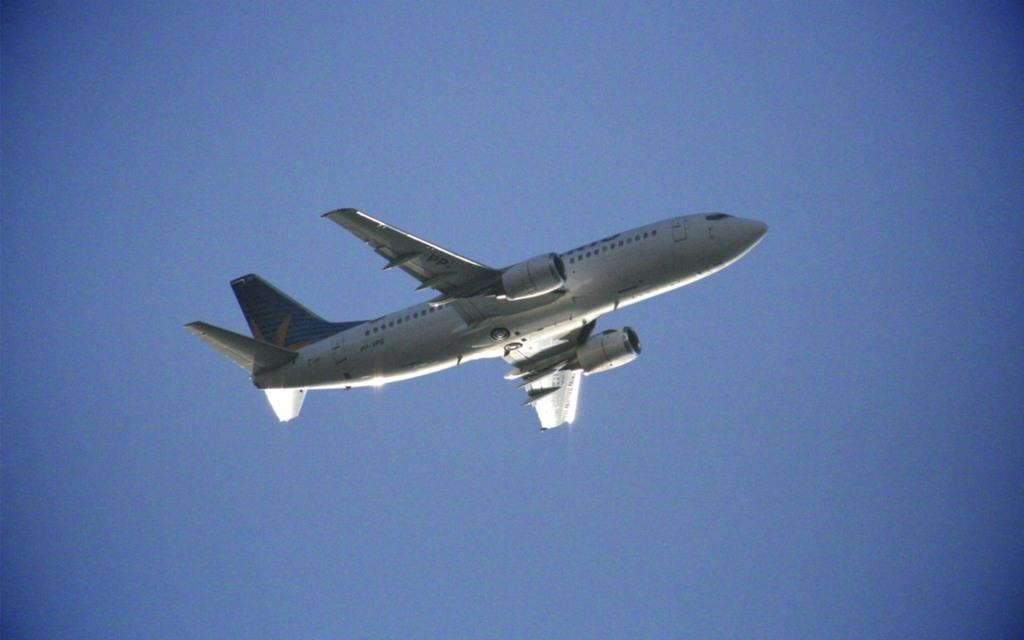What is the main subject of the image? The main subject of the image is an airplane. What is the airplane doing in the image? The airplane is flying in the sky. What type of bells can be heard ringing in the image? There are no bells present in the image, and therefore no sounds can be heard. 